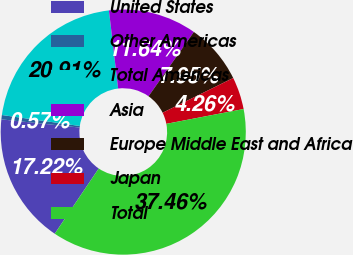<chart> <loc_0><loc_0><loc_500><loc_500><pie_chart><fcel>United States<fcel>Other Americas<fcel>Total Americas<fcel>Asia<fcel>Europe Middle East and Africa<fcel>Japan<fcel>Total<nl><fcel>17.22%<fcel>0.57%<fcel>20.91%<fcel>11.64%<fcel>7.95%<fcel>4.26%<fcel>37.46%<nl></chart> 